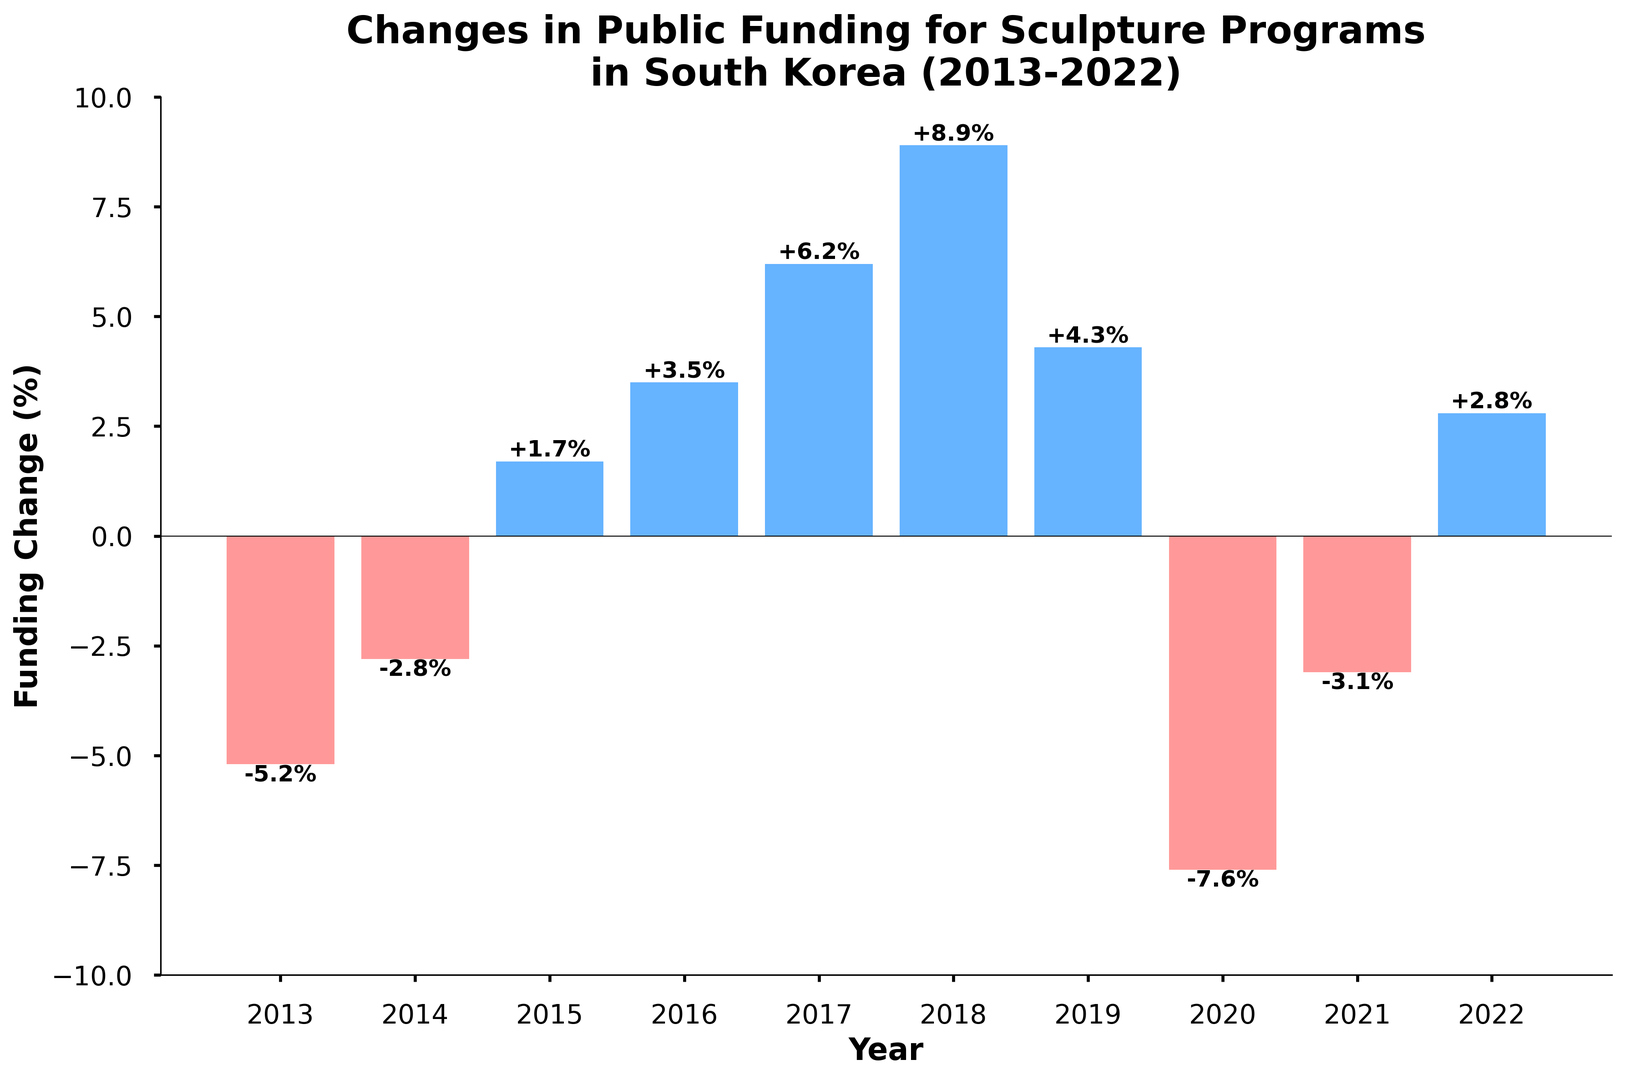Which year had the highest increase in public funding for sculpture programs? Based on the figure, the highest increase in public funding can be observed in 2018, as it shows the tallest blue bar.
Answer: 2018 What was the funding change percentage in 2020, and was it an increase or a decrease? The figure shows a red bar for 2020, indicating a negative change. The percentage shown on this bar is -7.6%.
Answer: -7.6%, decrease How many years experienced a decrease in funding, and what are those years? Decrease in funding is represented by red bars. According to the figure, there are four years with red bars: 2013, 2014, 2020, and 2021.
Answer: 4 years; 2013, 2014, 2020, 2021 What is the total percentage change in funding from 2013 to 2015? The percentage changes in 2013, 2014, and 2015 are -5.2%, -2.8%, and 1.7%, respectively. Sum these changes: -5.2 + (-2.8) + 1.7 = -6.3.
Answer: -6.3% Compare the funding change in 2017 with that in 2019. Which year had a higher increase, and by how much? The funding change in 2017 was 6.2%, and in 2019 it was 4.3%. The difference is 6.2% - 4.3% = 1.9%. So, 2017 had a higher increase by 1.9%.
Answer: 2017 by 1.9% What’s the average funding change over the years with positive growth? The years with positive growth are 2015, 2016, 2017, 2018, 2019, and 2022, with respective changes of 1.7%, 3.5%, 6.2%, 8.9%, 4.3%, and 2.8%. Calculate the average: (1.7 + 3.5 + 6.2 + 8.9 + 4.3 + 2.8) / 6 = 4.57%.
Answer: 4.57% What’s the difference in funding change between the highest and lowest values shown in the figure? The highest value is in 2018 with 8.9%, and the lowest value is in 2020 with -7.6%. The difference is 8.9 - (-7.6) = 16.5%.
Answer: 16.5% In which year did the funding change return to positive after being negative in 2020 and 2021? After the negative changes in 2020 (-7.6%) and 2021 (-3.1%), the funding change returned to positive in 2022 with a 2.8% increase.
Answer: 2022 